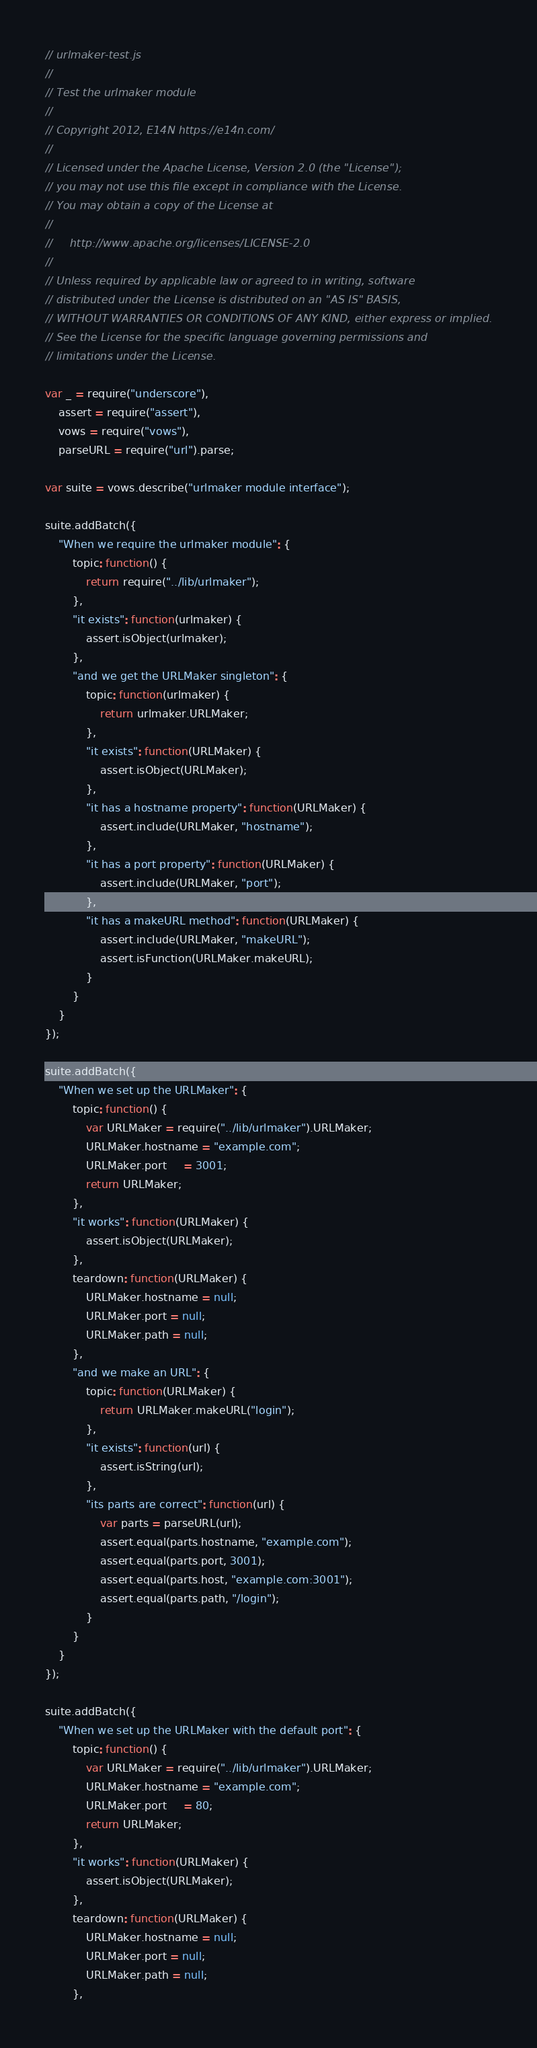Convert code to text. <code><loc_0><loc_0><loc_500><loc_500><_JavaScript_>// urlmaker-test.js
//
// Test the urlmaker module
//
// Copyright 2012, E14N https://e14n.com/
//
// Licensed under the Apache License, Version 2.0 (the "License");
// you may not use this file except in compliance with the License.
// You may obtain a copy of the License at
//
//     http://www.apache.org/licenses/LICENSE-2.0
//
// Unless required by applicable law or agreed to in writing, software
// distributed under the License is distributed on an "AS IS" BASIS,
// WITHOUT WARRANTIES OR CONDITIONS OF ANY KIND, either express or implied.
// See the License for the specific language governing permissions and
// limitations under the License.

var _ = require("underscore"),
    assert = require("assert"),
    vows = require("vows"),
    parseURL = require("url").parse;

var suite = vows.describe("urlmaker module interface");

suite.addBatch({
    "When we require the urlmaker module": {
        topic: function() {
            return require("../lib/urlmaker");
        },
        "it exists": function(urlmaker) {
            assert.isObject(urlmaker);
        },
        "and we get the URLMaker singleton": {
            topic: function(urlmaker) {
                return urlmaker.URLMaker;
            },
            "it exists": function(URLMaker) {
                assert.isObject(URLMaker);
            },
            "it has a hostname property": function(URLMaker) {
                assert.include(URLMaker, "hostname");
            },
            "it has a port property": function(URLMaker) {
                assert.include(URLMaker, "port");
            },
            "it has a makeURL method": function(URLMaker) {
                assert.include(URLMaker, "makeURL");
                assert.isFunction(URLMaker.makeURL);
            }
        }
    }
});

suite.addBatch({
    "When we set up the URLMaker": {
        topic: function() {
            var URLMaker = require("../lib/urlmaker").URLMaker;
            URLMaker.hostname = "example.com";
            URLMaker.port     = 3001;
            return URLMaker;
        },
        "it works": function(URLMaker) {
            assert.isObject(URLMaker);
        },
        teardown: function(URLMaker) {
            URLMaker.hostname = null;
            URLMaker.port = null;
            URLMaker.path = null;
        },
        "and we make an URL": {
            topic: function(URLMaker) {
                return URLMaker.makeURL("login");
            },
            "it exists": function(url) {
                assert.isString(url);
            },
            "its parts are correct": function(url) {
                var parts = parseURL(url);
                assert.equal(parts.hostname, "example.com");
                assert.equal(parts.port, 3001);
                assert.equal(parts.host, "example.com:3001");
                assert.equal(parts.path, "/login");
            }
        }
    }
});

suite.addBatch({
    "When we set up the URLMaker with the default port": {
        topic: function() {
            var URLMaker = require("../lib/urlmaker").URLMaker;
            URLMaker.hostname = "example.com";
            URLMaker.port     = 80;
            return URLMaker;
        },
        "it works": function(URLMaker) {
            assert.isObject(URLMaker);
        },
        teardown: function(URLMaker) {
            URLMaker.hostname = null;
            URLMaker.port = null;
            URLMaker.path = null;
        },</code> 